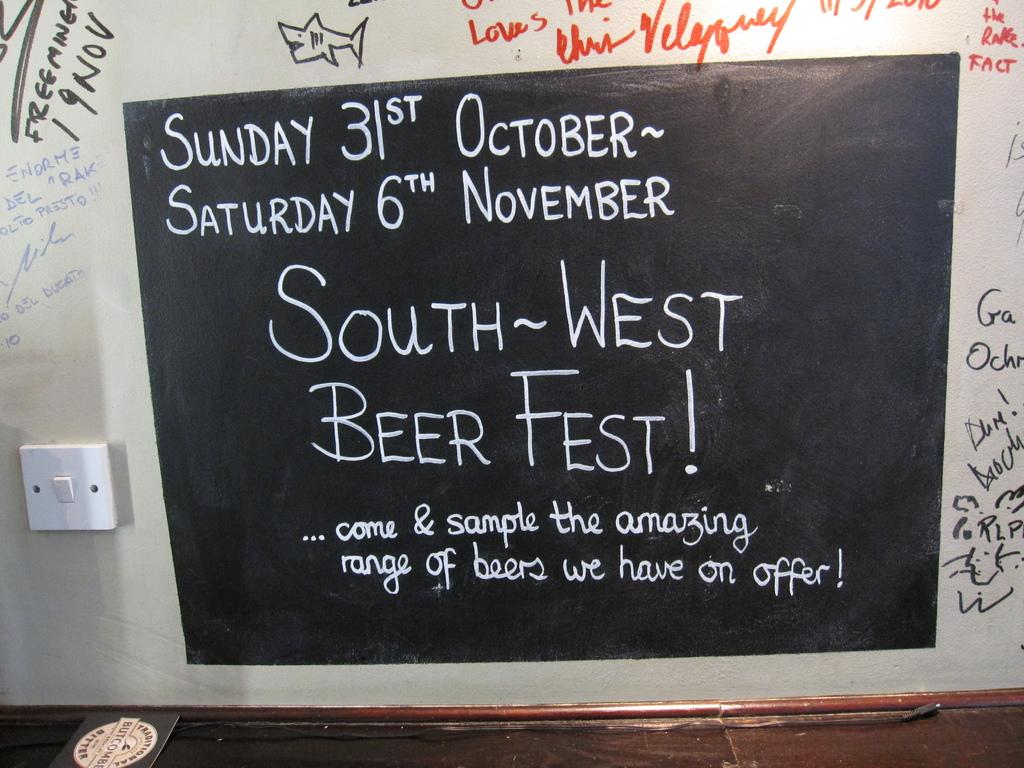Provide a one-sentence caption for the provided image. A black chalkboard displaying a message about a South West Beer Fest occurring from Sunday,October 31st to Saturday, November 6th. 